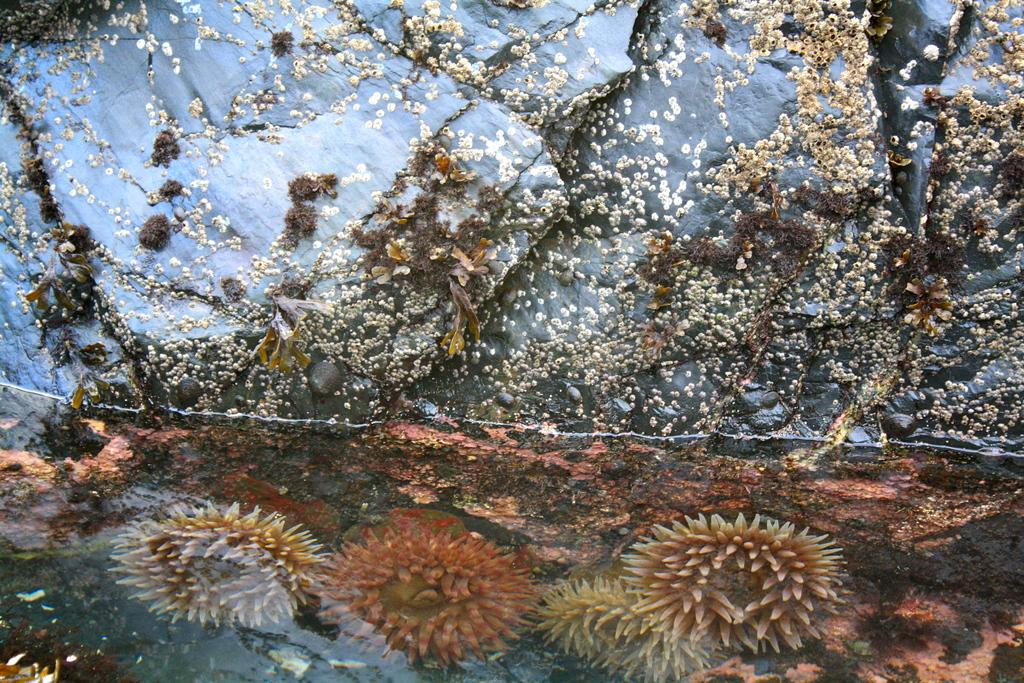What is inside the water in the image? There are plants inside the water in the image. What can be seen in the background of the image? There are rocks visible in the background of the image. How does the image compare to a painting of a similar scene? The image is not being compared to a painting in this context, as we are only focusing on the details present in the image itself. What season might the image be representative of? The image does not provide enough information to determine the season it might be representative of, as it only shows plants inside water and rocks in the background. 